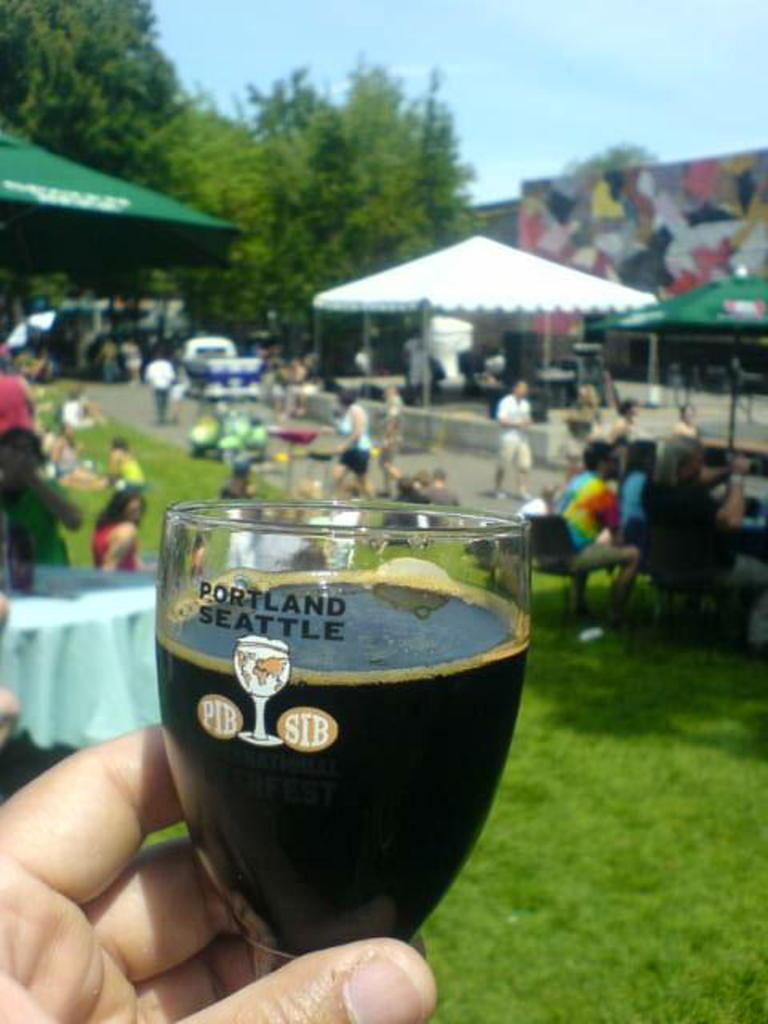Provide a one-sentence caption for the provided image. The persons beer glass is from Portland Seattle. 